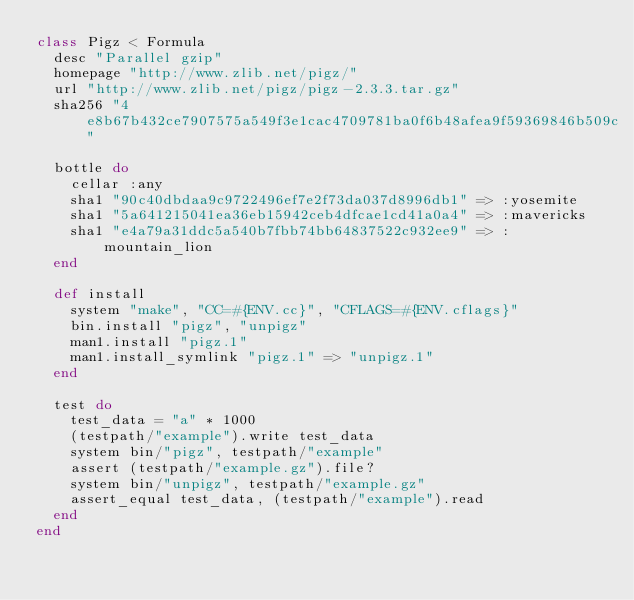Convert code to text. <code><loc_0><loc_0><loc_500><loc_500><_Ruby_>class Pigz < Formula
  desc "Parallel gzip"
  homepage "http://www.zlib.net/pigz/"
  url "http://www.zlib.net/pigz/pigz-2.3.3.tar.gz"
  sha256 "4e8b67b432ce7907575a549f3e1cac4709781ba0f6b48afea9f59369846b509c"

  bottle do
    cellar :any
    sha1 "90c40dbdaa9c9722496ef7e2f73da037d8996db1" => :yosemite
    sha1 "5a641215041ea36eb15942ceb4dfcae1cd41a0a4" => :mavericks
    sha1 "e4a79a31ddc5a540b7fbb74bb64837522c932ee9" => :mountain_lion
  end

  def install
    system "make", "CC=#{ENV.cc}", "CFLAGS=#{ENV.cflags}"
    bin.install "pigz", "unpigz"
    man1.install "pigz.1"
    man1.install_symlink "pigz.1" => "unpigz.1"
  end

  test do
    test_data = "a" * 1000
    (testpath/"example").write test_data
    system bin/"pigz", testpath/"example"
    assert (testpath/"example.gz").file?
    system bin/"unpigz", testpath/"example.gz"
    assert_equal test_data, (testpath/"example").read
  end
end
</code> 